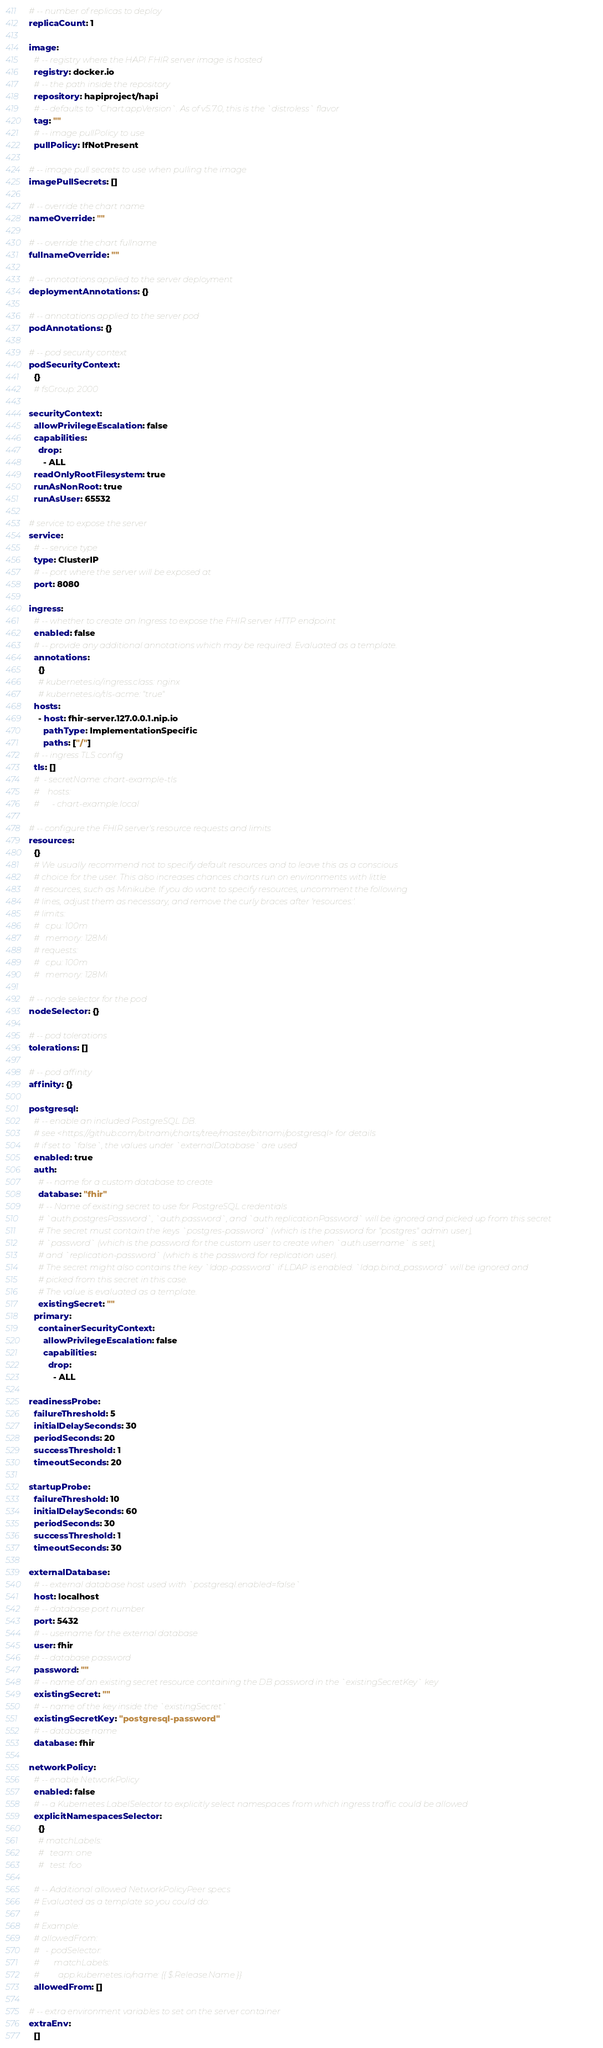Convert code to text. <code><loc_0><loc_0><loc_500><loc_500><_YAML_># -- number of replicas to deploy
replicaCount: 1

image:
  # -- registry where the HAPI FHIR server image is hosted
  registry: docker.io
  # -- the path inside the repository
  repository: hapiproject/hapi
  # -- defaults to `Chart.appVersion`. As of v5.7.0, this is the `distroless` flavor
  tag: ""
  # -- image pullPolicy to use
  pullPolicy: IfNotPresent

# -- image pull secrets to use when pulling the image
imagePullSecrets: []

# -- override the chart name
nameOverride: ""

# -- override the chart fullname
fullnameOverride: ""

# -- annotations applied to the server deployment
deploymentAnnotations: {}

# -- annotations applied to the server pod
podAnnotations: {}

# -- pod security context
podSecurityContext:
  {}
  # fsGroup: 2000

securityContext:
  allowPrivilegeEscalation: false
  capabilities:
    drop:
      - ALL
  readOnlyRootFilesystem: true
  runAsNonRoot: true
  runAsUser: 65532

# service to expose the server
service:
  # -- service type
  type: ClusterIP
  # -- port where the server will be exposed at
  port: 8080

ingress:
  # -- whether to create an Ingress to expose the FHIR server HTTP endpoint
  enabled: false
  # -- provide any additional annotations which may be required. Evaluated as a template.
  annotations:
    {}
    # kubernetes.io/ingress.class: nginx
    # kubernetes.io/tls-acme: "true"
  hosts:
    - host: fhir-server.127.0.0.1.nip.io
      pathType: ImplementationSpecific
      paths: ["/"]
  # -- ingress TLS config
  tls: []
  #  - secretName: chart-example-tls
  #    hosts:
  #      - chart-example.local

# -- configure the FHIR server's resource requests and limits
resources:
  {}
  # We usually recommend not to specify default resources and to leave this as a conscious
  # choice for the user. This also increases chances charts run on environments with little
  # resources, such as Minikube. If you do want to specify resources, uncomment the following
  # lines, adjust them as necessary, and remove the curly braces after 'resources:'.
  # limits:
  #   cpu: 100m
  #   memory: 128Mi
  # requests:
  #   cpu: 100m
  #   memory: 128Mi

# -- node selector for the pod
nodeSelector: {}

# -- pod tolerations
tolerations: []

# -- pod affinity
affinity: {}

postgresql:
  # -- enable an included PostgreSQL DB.
  # see <https://github.com/bitnami/charts/tree/master/bitnami/postgresql> for details
  # if set to `false`, the values under `externalDatabase` are used
  enabled: true
  auth:
    # -- name for a custom database to create
    database: "fhir"
    # -- Name of existing secret to use for PostgreSQL credentials
    # `auth.postgresPassword`, `auth.password`, and `auth.replicationPassword` will be ignored and picked up from this secret
    # The secret must contain the keys `postgres-password` (which is the password for "postgres" admin user),
    # `password` (which is the password for the custom user to create when `auth.username` is set),
    # and `replication-password` (which is the password for replication user).
    # The secret might also contains the key `ldap-password` if LDAP is enabled. `ldap.bind_password` will be ignored and
    # picked from this secret in this case.
    # The value is evaluated as a template.
    existingSecret: ""
  primary:
    containerSecurityContext:
      allowPrivilegeEscalation: false
      capabilities:
        drop:
          - ALL

readinessProbe:
  failureThreshold: 5
  initialDelaySeconds: 30
  periodSeconds: 20
  successThreshold: 1
  timeoutSeconds: 20

startupProbe:
  failureThreshold: 10
  initialDelaySeconds: 60
  periodSeconds: 30
  successThreshold: 1
  timeoutSeconds: 30

externalDatabase:
  # -- external database host used with `postgresql.enabled=false`
  host: localhost
  # -- database port number
  port: 5432
  # -- username for the external database
  user: fhir
  # -- database password
  password: ""
  # -- name of an existing secret resource containing the DB password in the `existingSecretKey` key
  existingSecret: ""
  # -- name of the key inside the `existingSecret`
  existingSecretKey: "postgresql-password"
  # -- database name
  database: fhir

networkPolicy:
  # -- enable NetworkPolicy
  enabled: false
  # -- a Kubernetes LabelSelector to explicitly select namespaces from which ingress traffic could be allowed
  explicitNamespacesSelector:
    {}
    # matchLabels:
    #   team: one
    #   test: foo

  # -- Additional allowed NetworkPolicyPeer specs
  # Evaluated as a template so you could do:
  #
  # Example:
  # allowedFrom:
  #   - podSelector:
  #       matchLabels:
  #         app.kubernetes.io/name: {{ $.Release.Name }}
  allowedFrom: []

# -- extra environment variables to set on the server container
extraEnv:
  []</code> 